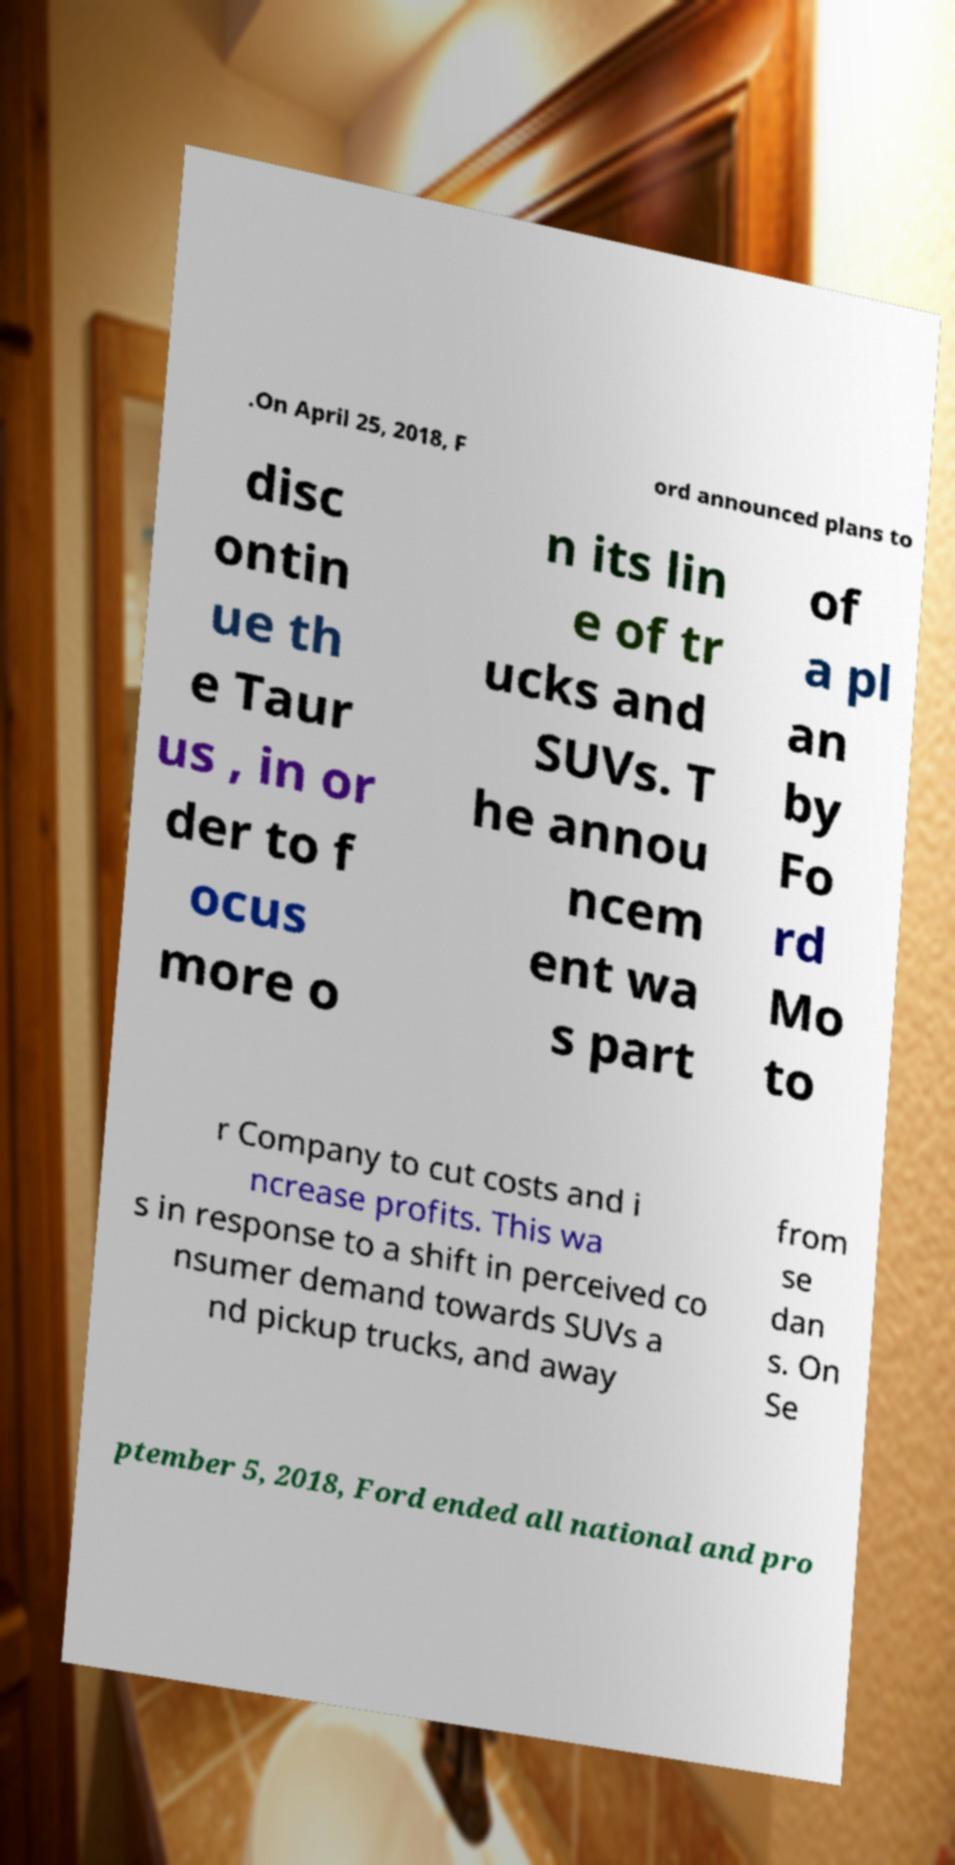Could you extract and type out the text from this image? .On April 25, 2018, F ord announced plans to disc ontin ue th e Taur us , in or der to f ocus more o n its lin e of tr ucks and SUVs. T he annou ncem ent wa s part of a pl an by Fo rd Mo to r Company to cut costs and i ncrease profits. This wa s in response to a shift in perceived co nsumer demand towards SUVs a nd pickup trucks, and away from se dan s. On Se ptember 5, 2018, Ford ended all national and pro 